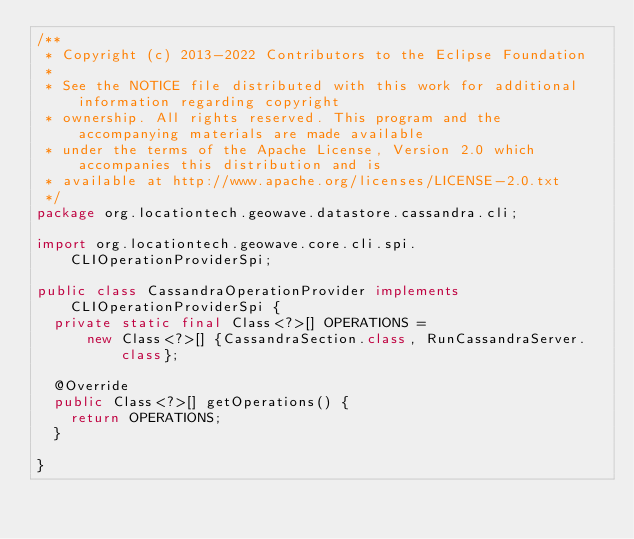<code> <loc_0><loc_0><loc_500><loc_500><_Java_>/**
 * Copyright (c) 2013-2022 Contributors to the Eclipse Foundation
 * 
 * See the NOTICE file distributed with this work for additional information regarding copyright
 * ownership. All rights reserved. This program and the accompanying materials are made available
 * under the terms of the Apache License, Version 2.0 which accompanies this distribution and is
 * available at http://www.apache.org/licenses/LICENSE-2.0.txt
 */
package org.locationtech.geowave.datastore.cassandra.cli;

import org.locationtech.geowave.core.cli.spi.CLIOperationProviderSpi;

public class CassandraOperationProvider implements CLIOperationProviderSpi {
  private static final Class<?>[] OPERATIONS =
      new Class<?>[] {CassandraSection.class, RunCassandraServer.class};

  @Override
  public Class<?>[] getOperations() {
    return OPERATIONS;
  }

}
</code> 